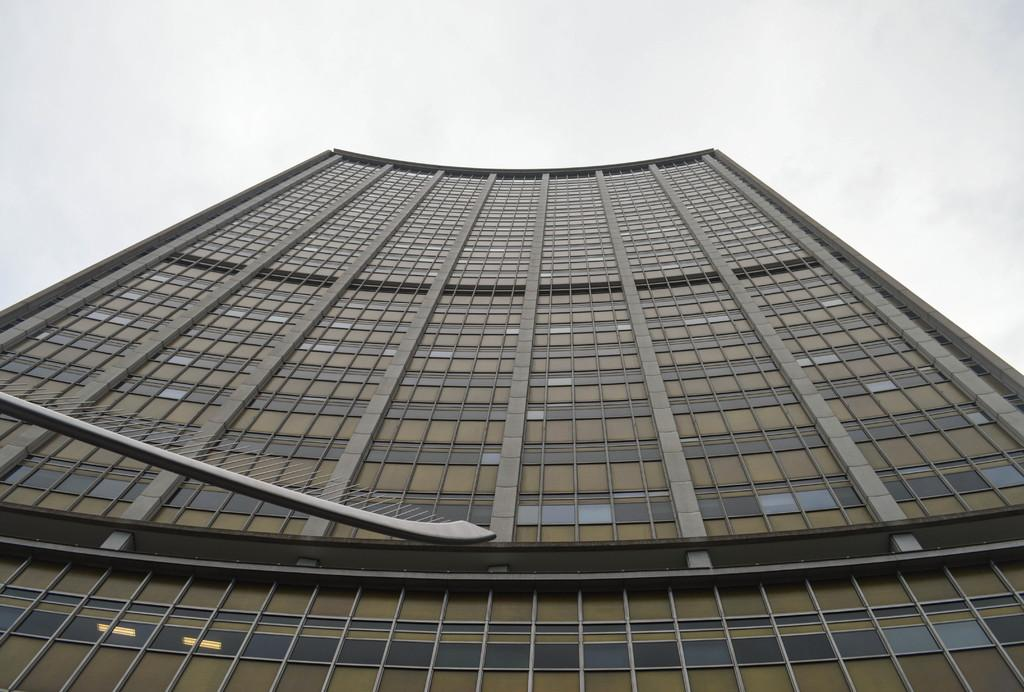What type of structure is present in the image? There is a building in the image. What can be seen at the top of the image? The sky is visible at the top of the image. What type of camera is being used to take the picture of the building? There is no information about a camera being used to take the picture, as we are only looking at the image itself. Can you hear the horn of a vehicle in the image? There is no sound present in the image, so it is not possible to hear a horn or any other noise. 